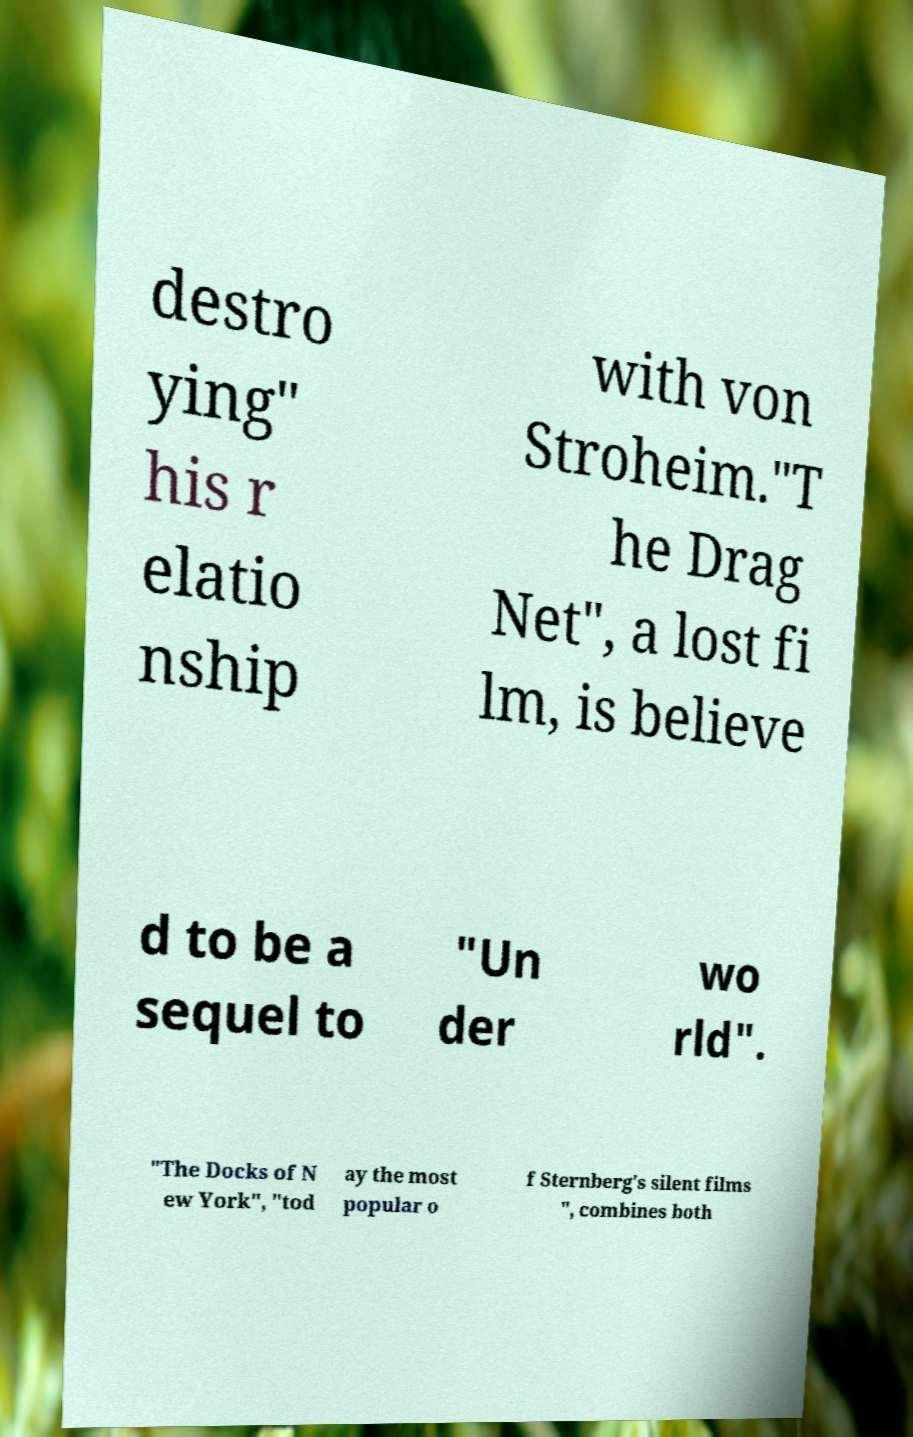Please read and relay the text visible in this image. What does it say? destro ying" his r elatio nship with von Stroheim."T he Drag Net", a lost fi lm, is believe d to be a sequel to "Un der wo rld". "The Docks of N ew York", "tod ay the most popular o f Sternberg's silent films ", combines both 